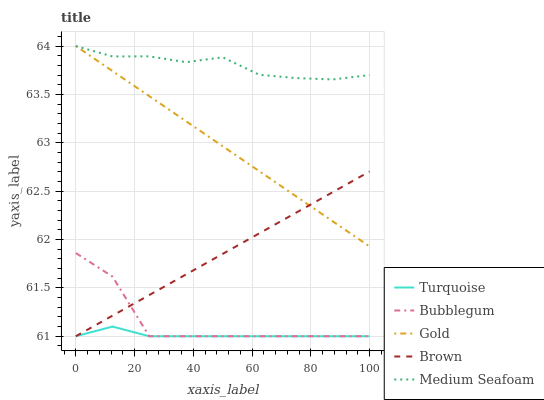Does Turquoise have the minimum area under the curve?
Answer yes or no. Yes. Does Medium Seafoam have the maximum area under the curve?
Answer yes or no. Yes. Does Gold have the minimum area under the curve?
Answer yes or no. No. Does Gold have the maximum area under the curve?
Answer yes or no. No. Is Gold the smoothest?
Answer yes or no. Yes. Is Bubblegum the roughest?
Answer yes or no. Yes. Is Turquoise the smoothest?
Answer yes or no. No. Is Turquoise the roughest?
Answer yes or no. No. Does Brown have the lowest value?
Answer yes or no. Yes. Does Gold have the lowest value?
Answer yes or no. No. Does Medium Seafoam have the highest value?
Answer yes or no. Yes. Does Turquoise have the highest value?
Answer yes or no. No. Is Turquoise less than Medium Seafoam?
Answer yes or no. Yes. Is Medium Seafoam greater than Turquoise?
Answer yes or no. Yes. Does Medium Seafoam intersect Gold?
Answer yes or no. Yes. Is Medium Seafoam less than Gold?
Answer yes or no. No. Is Medium Seafoam greater than Gold?
Answer yes or no. No. Does Turquoise intersect Medium Seafoam?
Answer yes or no. No. 